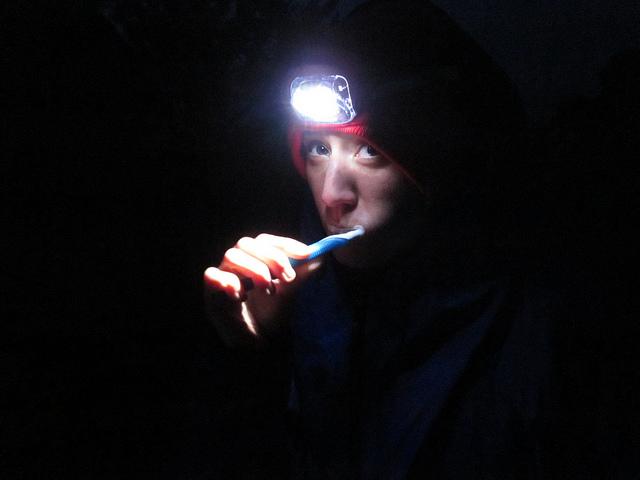Could that be a headlamp?
Give a very brief answer. Yes. What is the person doing?
Keep it brief. Brushing teeth. Is the person trapped?
Short answer required. No. Is the guy doing a trick?
Short answer required. No. 